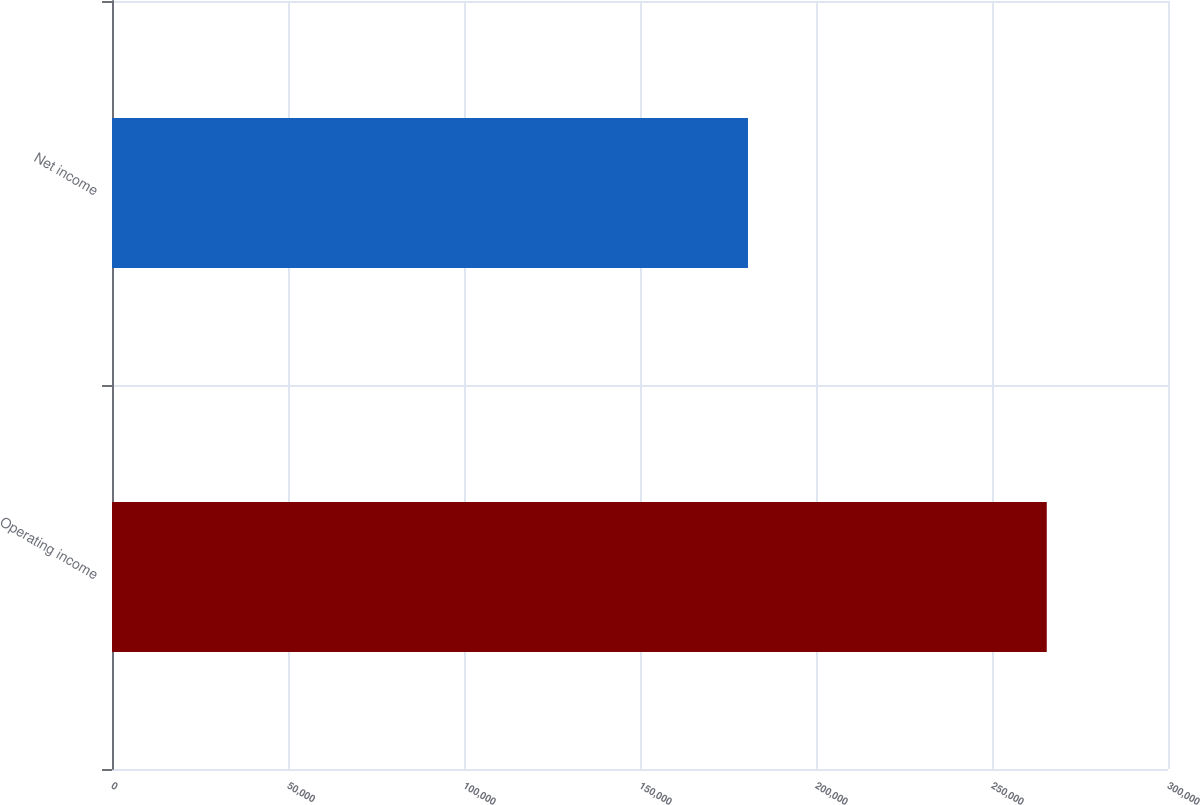<chart> <loc_0><loc_0><loc_500><loc_500><bar_chart><fcel>Operating income<fcel>Net income<nl><fcel>265559<fcel>180675<nl></chart> 